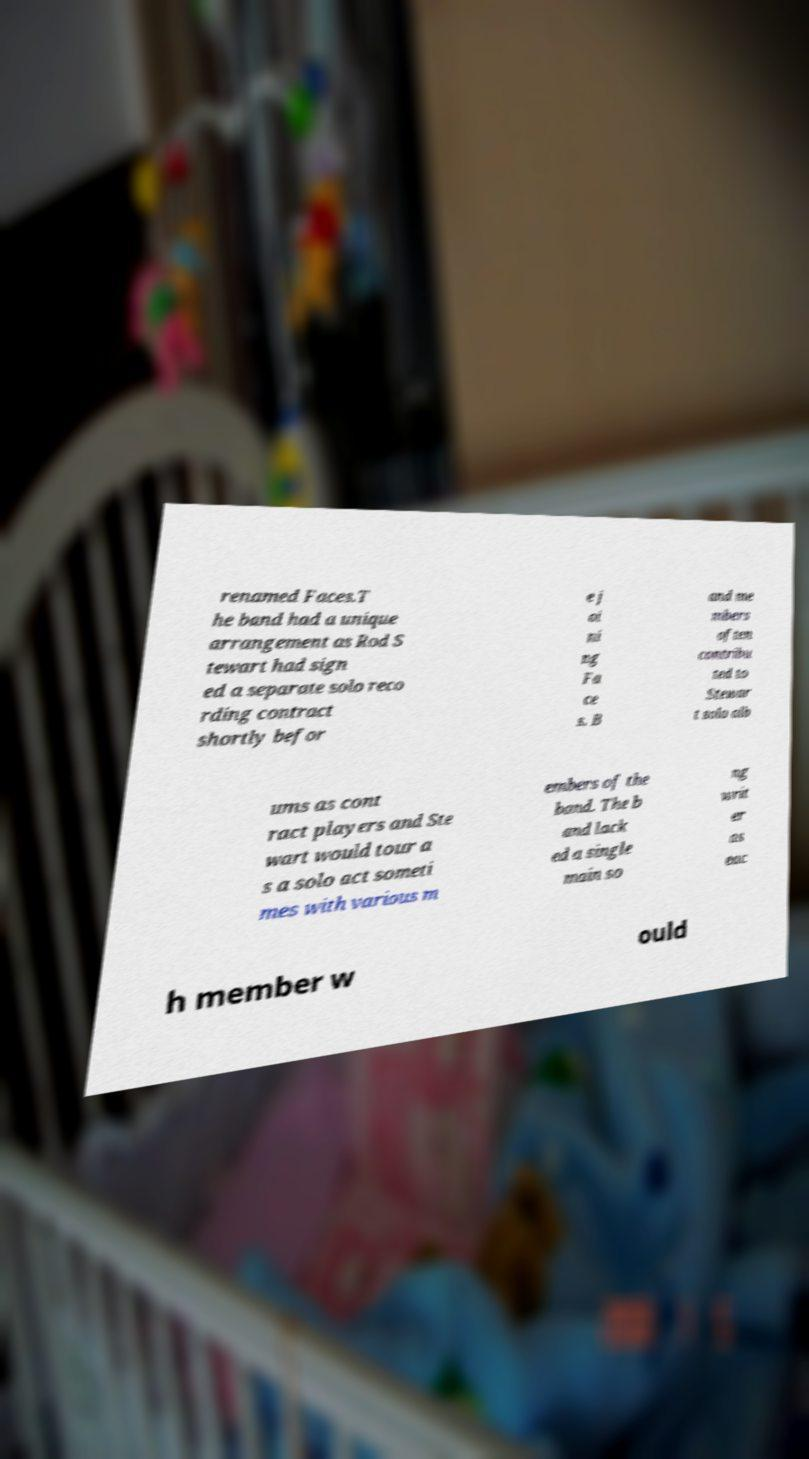There's text embedded in this image that I need extracted. Can you transcribe it verbatim? renamed Faces.T he band had a unique arrangement as Rod S tewart had sign ed a separate solo reco rding contract shortly befor e j oi ni ng Fa ce s. B and me mbers often contribu ted to Stewar t solo alb ums as cont ract players and Ste wart would tour a s a solo act someti mes with various m embers of the band. The b and lack ed a single main so ng writ er as eac h member w ould 